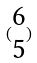<formula> <loc_0><loc_0><loc_500><loc_500>( \begin{matrix} 6 \\ 5 \end{matrix} )</formula> 